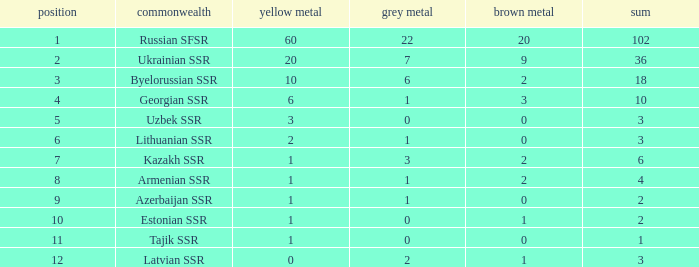What is the average total for teams with more than 1 gold, ranked over 3 and more than 3 bronze? None. 